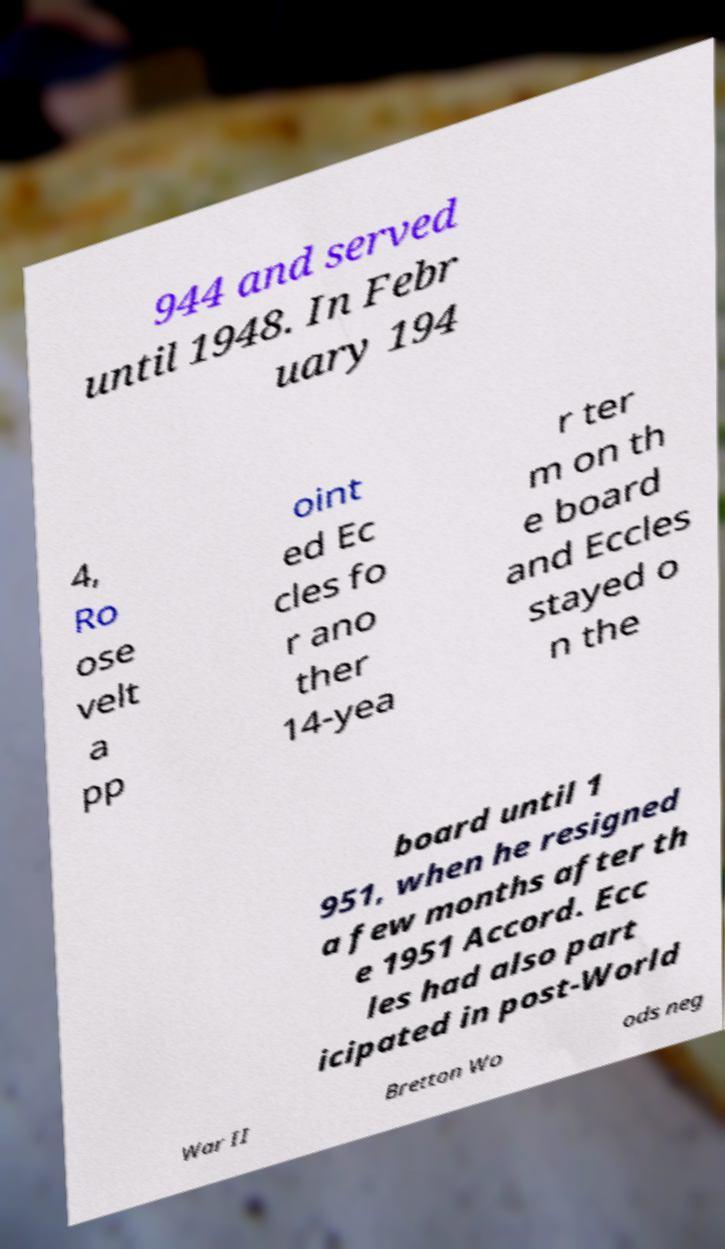What messages or text are displayed in this image? I need them in a readable, typed format. 944 and served until 1948. In Febr uary 194 4, Ro ose velt a pp oint ed Ec cles fo r ano ther 14-yea r ter m on th e board and Eccles stayed o n the board until 1 951, when he resigned a few months after th e 1951 Accord. Ecc les had also part icipated in post-World War II Bretton Wo ods neg 